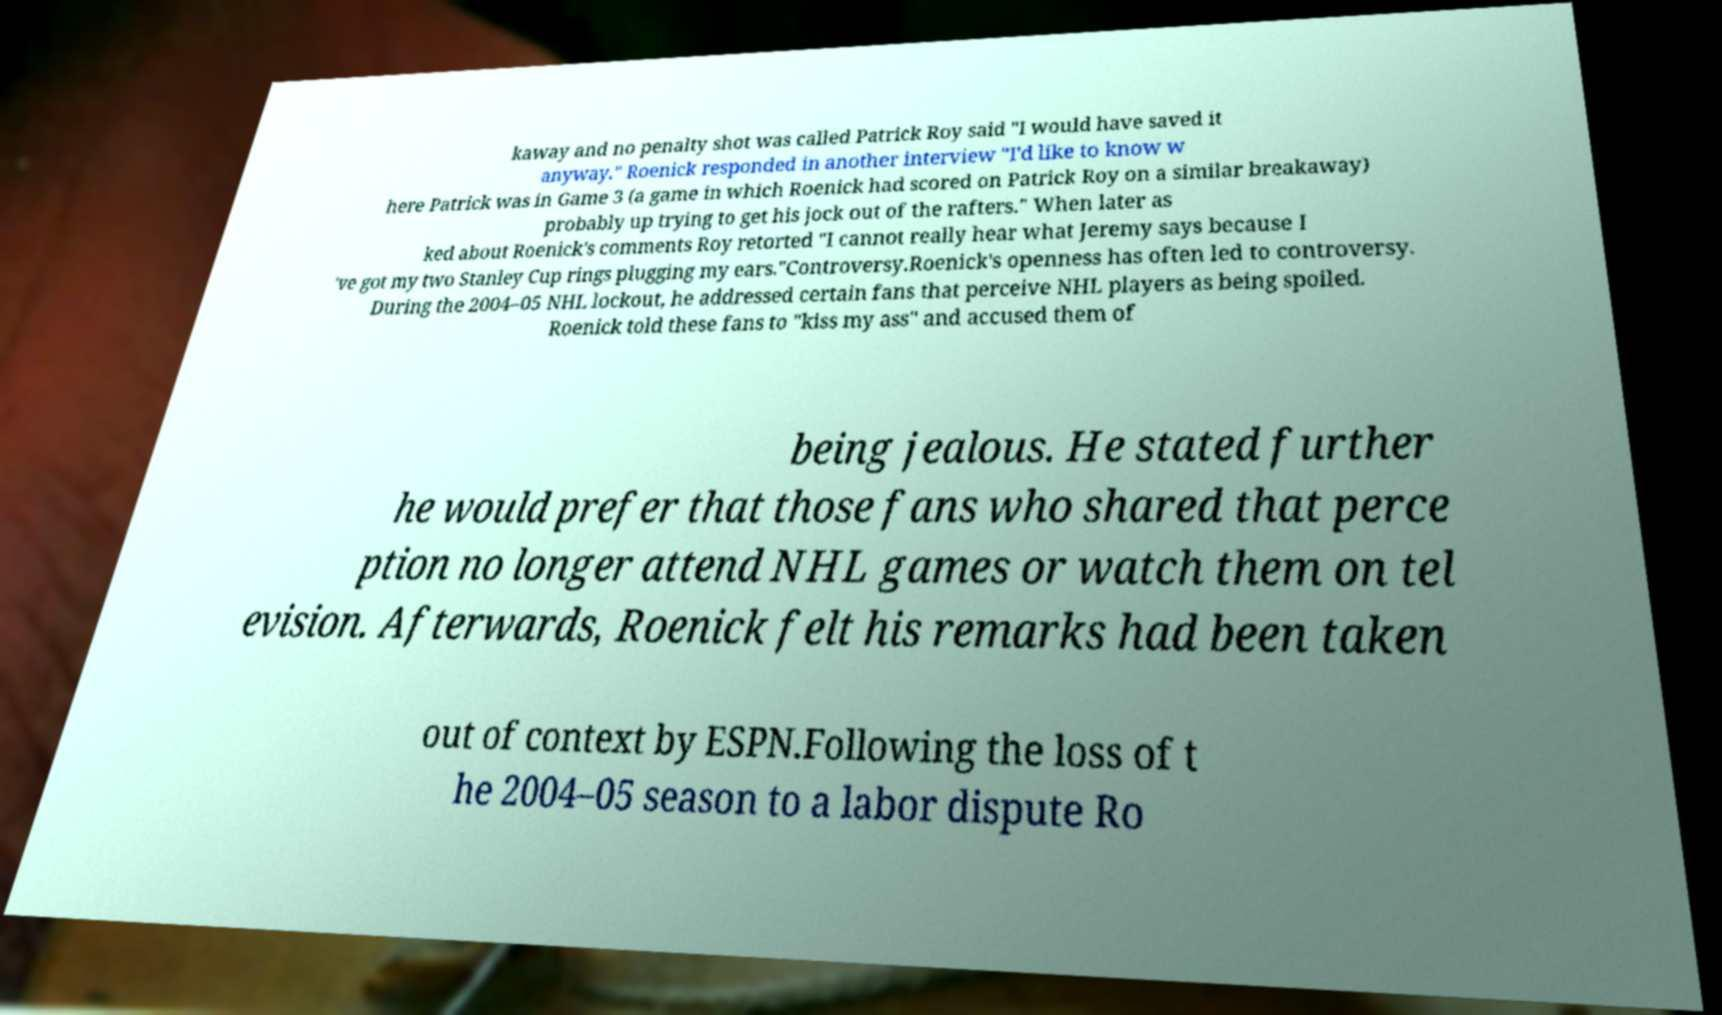Please identify and transcribe the text found in this image. kaway and no penalty shot was called Patrick Roy said "I would have saved it anyway." Roenick responded in another interview "I'd like to know w here Patrick was in Game 3 (a game in which Roenick had scored on Patrick Roy on a similar breakaway) probably up trying to get his jock out of the rafters." When later as ked about Roenick's comments Roy retorted "I cannot really hear what Jeremy says because I 've got my two Stanley Cup rings plugging my ears."Controversy.Roenick's openness has often led to controversy. During the 2004–05 NHL lockout, he addressed certain fans that perceive NHL players as being spoiled. Roenick told these fans to "kiss my ass" and accused them of being jealous. He stated further he would prefer that those fans who shared that perce ption no longer attend NHL games or watch them on tel evision. Afterwards, Roenick felt his remarks had been taken out of context by ESPN.Following the loss of t he 2004–05 season to a labor dispute Ro 